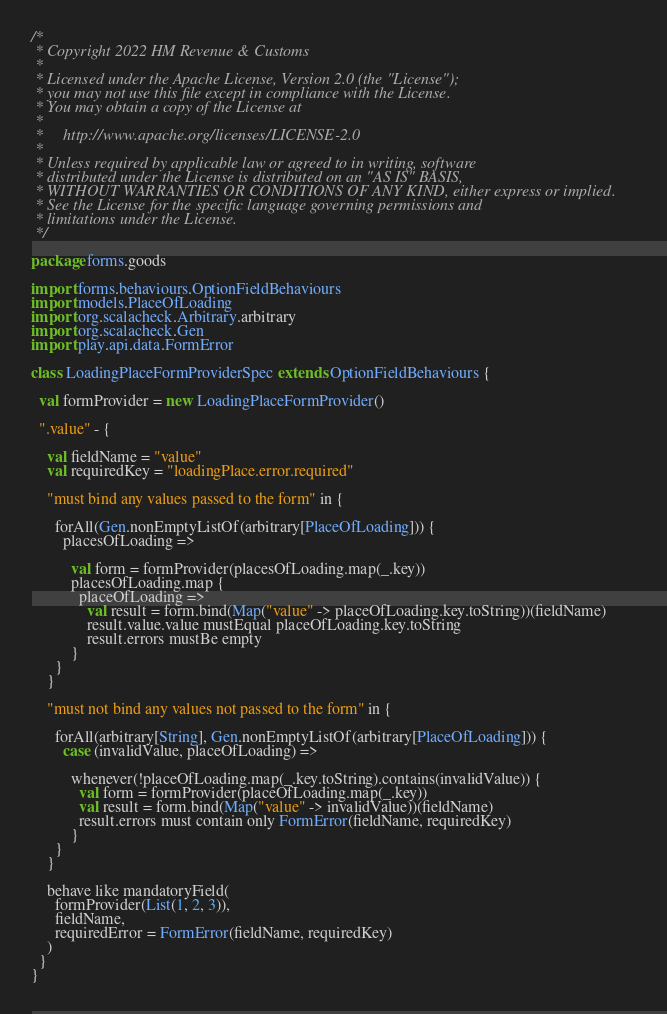<code> <loc_0><loc_0><loc_500><loc_500><_Scala_>/*
 * Copyright 2022 HM Revenue & Customs
 *
 * Licensed under the Apache License, Version 2.0 (the "License");
 * you may not use this file except in compliance with the License.
 * You may obtain a copy of the License at
 *
 *     http://www.apache.org/licenses/LICENSE-2.0
 *
 * Unless required by applicable law or agreed to in writing, software
 * distributed under the License is distributed on an "AS IS" BASIS,
 * WITHOUT WARRANTIES OR CONDITIONS OF ANY KIND, either express or implied.
 * See the License for the specific language governing permissions and
 * limitations under the License.
 */

package forms.goods

import forms.behaviours.OptionFieldBehaviours
import models.PlaceOfLoading
import org.scalacheck.Arbitrary.arbitrary
import org.scalacheck.Gen
import play.api.data.FormError

class LoadingPlaceFormProviderSpec extends OptionFieldBehaviours {

  val formProvider = new LoadingPlaceFormProvider()

  ".value" - {

    val fieldName = "value"
    val requiredKey = "loadingPlace.error.required"

    "must bind any values passed to the form" in {

      forAll(Gen.nonEmptyListOf(arbitrary[PlaceOfLoading])) {
        placesOfLoading =>

          val form = formProvider(placesOfLoading.map(_.key))
          placesOfLoading.map {
            placeOfLoading =>
              val result = form.bind(Map("value" -> placeOfLoading.key.toString))(fieldName)
              result.value.value mustEqual placeOfLoading.key.toString
              result.errors mustBe empty
          }
      }
    }

    "must not bind any values not passed to the form" in {

      forAll(arbitrary[String], Gen.nonEmptyListOf(arbitrary[PlaceOfLoading])) {
        case (invalidValue, placeOfLoading) =>

          whenever(!placeOfLoading.map(_.key.toString).contains(invalidValue)) {
            val form = formProvider(placeOfLoading.map(_.key))
            val result = form.bind(Map("value" -> invalidValue))(fieldName)
            result.errors must contain only FormError(fieldName, requiredKey)
          }
      }
    }

    behave like mandatoryField(
      formProvider(List(1, 2, 3)),
      fieldName,
      requiredError = FormError(fieldName, requiredKey)
    )
  }
}
</code> 